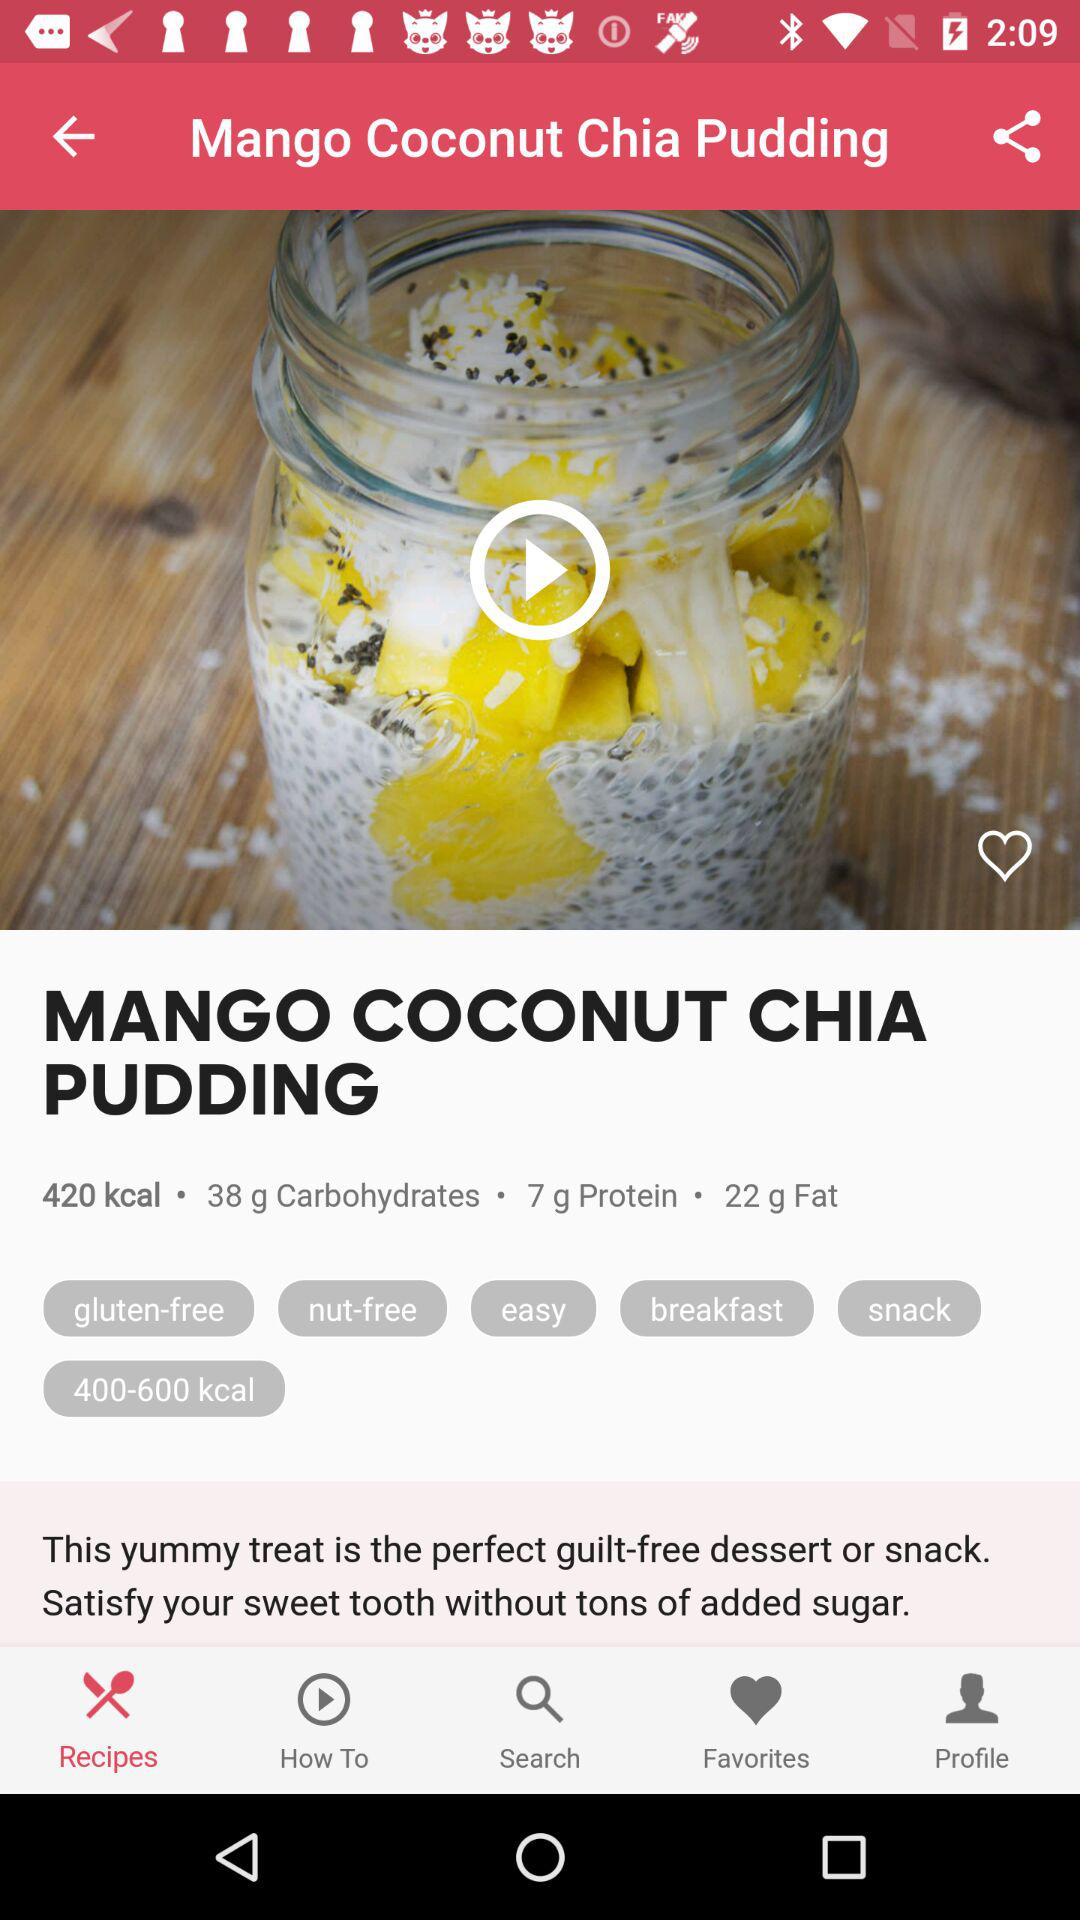How many carbs are in this recipe? The Mango Coconut Chia Pudding contains 38 grams of carbohydrates. It's a satisfying option with a balance of sweetness and nutrition, perfect for a healthy dessert or snack. 